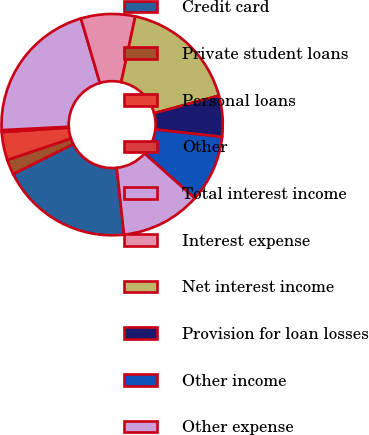Convert chart to OTSL. <chart><loc_0><loc_0><loc_500><loc_500><pie_chart><fcel>Credit card<fcel>Private student loans<fcel>Personal loans<fcel>Other<fcel>Total interest income<fcel>Interest expense<fcel>Net interest income<fcel>Provision for loan losses<fcel>Other income<fcel>Other expense<nl><fcel>19.33%<fcel>2.2%<fcel>4.1%<fcel>0.29%<fcel>21.23%<fcel>7.91%<fcel>17.42%<fcel>6.0%<fcel>9.81%<fcel>11.71%<nl></chart> 